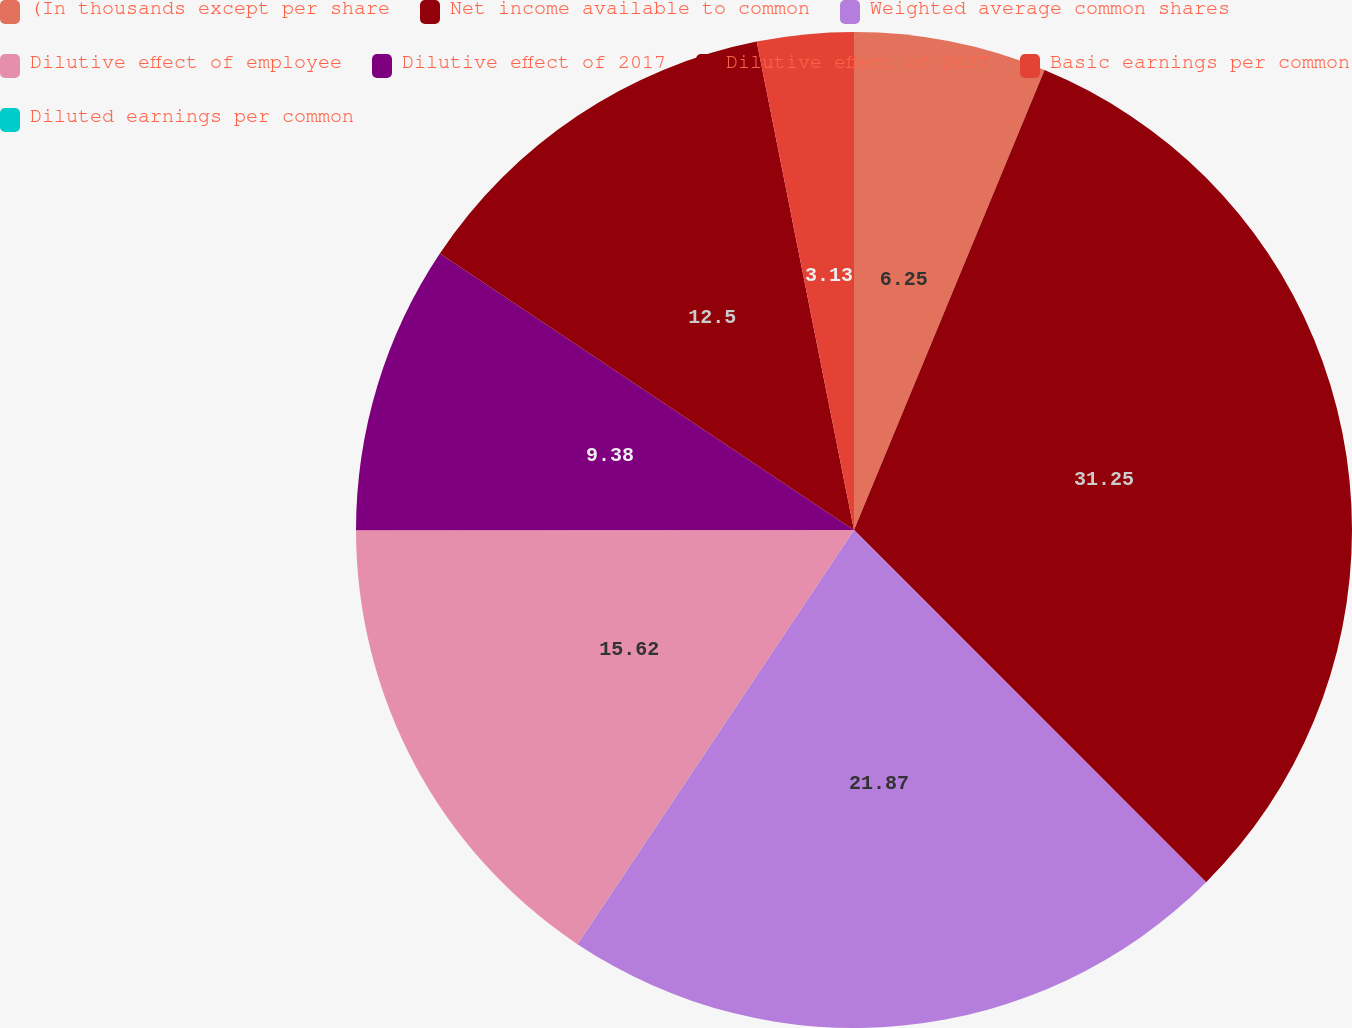Convert chart to OTSL. <chart><loc_0><loc_0><loc_500><loc_500><pie_chart><fcel>(In thousands except per share<fcel>Net income available to common<fcel>Weighted average common shares<fcel>Dilutive effect of employee<fcel>Dilutive effect of 2017<fcel>Dilutive effect of 2037<fcel>Basic earnings per common<fcel>Diluted earnings per common<nl><fcel>6.25%<fcel>31.25%<fcel>21.87%<fcel>15.62%<fcel>9.38%<fcel>12.5%<fcel>3.13%<fcel>0.0%<nl></chart> 